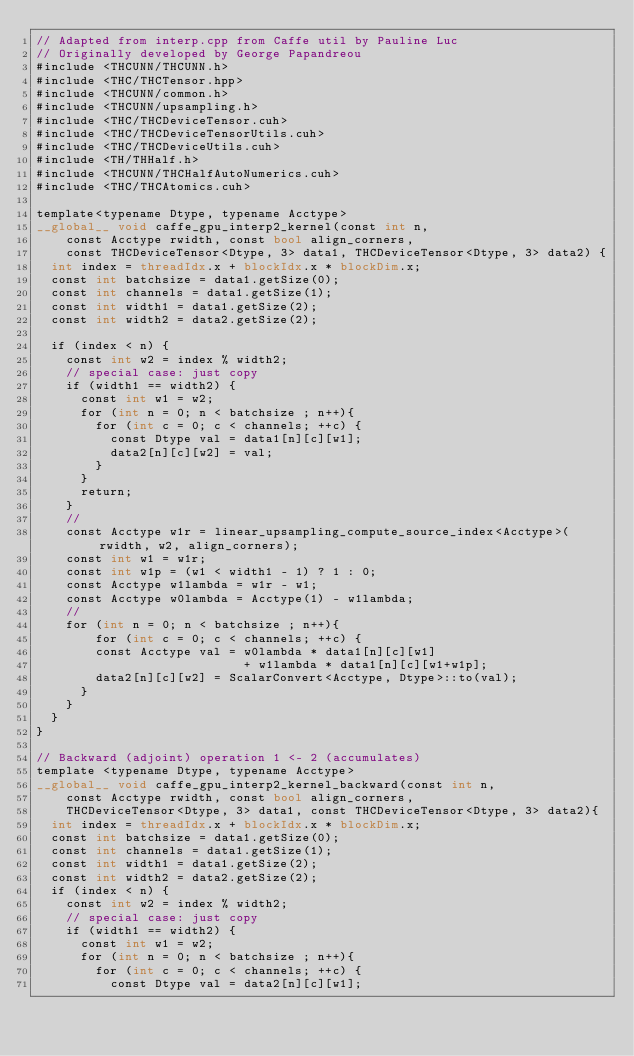<code> <loc_0><loc_0><loc_500><loc_500><_Cuda_>// Adapted from interp.cpp from Caffe util by Pauline Luc
// Originally developed by George Papandreou
#include <THCUNN/THCUNN.h>
#include <THC/THCTensor.hpp>
#include <THCUNN/common.h>
#include <THCUNN/upsampling.h>
#include <THC/THCDeviceTensor.cuh>
#include <THC/THCDeviceTensorUtils.cuh>
#include <THC/THCDeviceUtils.cuh>
#include <TH/THHalf.h>
#include <THCUNN/THCHalfAutoNumerics.cuh>
#include <THC/THCAtomics.cuh>

template<typename Dtype, typename Acctype>
__global__ void caffe_gpu_interp2_kernel(const int n,
    const Acctype rwidth, const bool align_corners,
    const THCDeviceTensor<Dtype, 3> data1, THCDeviceTensor<Dtype, 3> data2) {
  int index = threadIdx.x + blockIdx.x * blockDim.x;
  const int batchsize = data1.getSize(0);
  const int channels = data1.getSize(1);
  const int width1 = data1.getSize(2);
  const int width2 = data2.getSize(2);

  if (index < n) {
    const int w2 = index % width2;
    // special case: just copy
    if (width1 == width2) {
      const int w1 = w2;
      for (int n = 0; n < batchsize ; n++){
        for (int c = 0; c < channels; ++c) {
          const Dtype val = data1[n][c][w1];
          data2[n][c][w2] = val;
        }
      }
      return;
    }
    //
    const Acctype w1r = linear_upsampling_compute_source_index<Acctype>(rwidth, w2, align_corners);
    const int w1 = w1r;
    const int w1p = (w1 < width1 - 1) ? 1 : 0;
    const Acctype w1lambda = w1r - w1;
    const Acctype w0lambda = Acctype(1) - w1lambda;
    //
    for (int n = 0; n < batchsize ; n++){
        for (int c = 0; c < channels; ++c) {
        const Acctype val = w0lambda * data1[n][c][w1]
                            + w1lambda * data1[n][c][w1+w1p];
        data2[n][c][w2] = ScalarConvert<Acctype, Dtype>::to(val);
      }
    }
  }
}

// Backward (adjoint) operation 1 <- 2 (accumulates)
template <typename Dtype, typename Acctype>
__global__ void caffe_gpu_interp2_kernel_backward(const int n,
    const Acctype rwidth, const bool align_corners,
    THCDeviceTensor<Dtype, 3> data1, const THCDeviceTensor<Dtype, 3> data2){
  int index = threadIdx.x + blockIdx.x * blockDim.x;
  const int batchsize = data1.getSize(0);
  const int channels = data1.getSize(1);
  const int width1 = data1.getSize(2);
  const int width2 = data2.getSize(2);
  if (index < n) {
    const int w2 = index % width2;
    // special case: just copy
    if (width1 == width2) {
      const int w1 = w2;
      for (int n = 0; n < batchsize ; n++){
        for (int c = 0; c < channels; ++c) {
          const Dtype val = data2[n][c][w1];</code> 